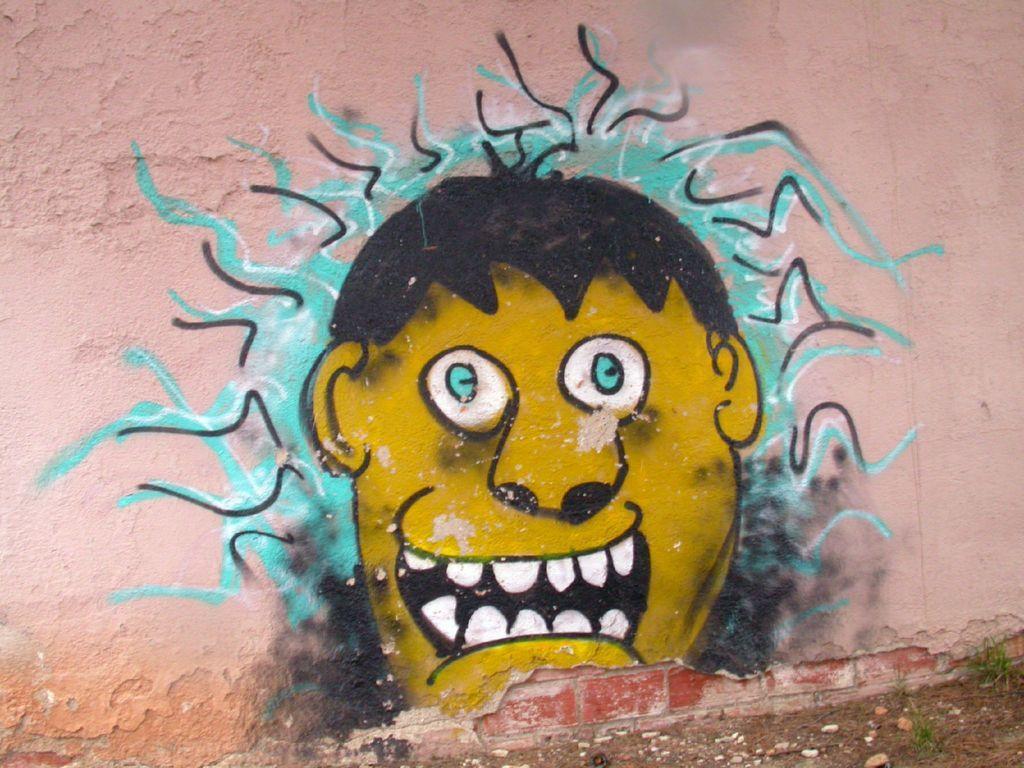In one or two sentences, can you explain what this image depicts? In this image there is a wall and we can see a painting of a man's face on the wall. 